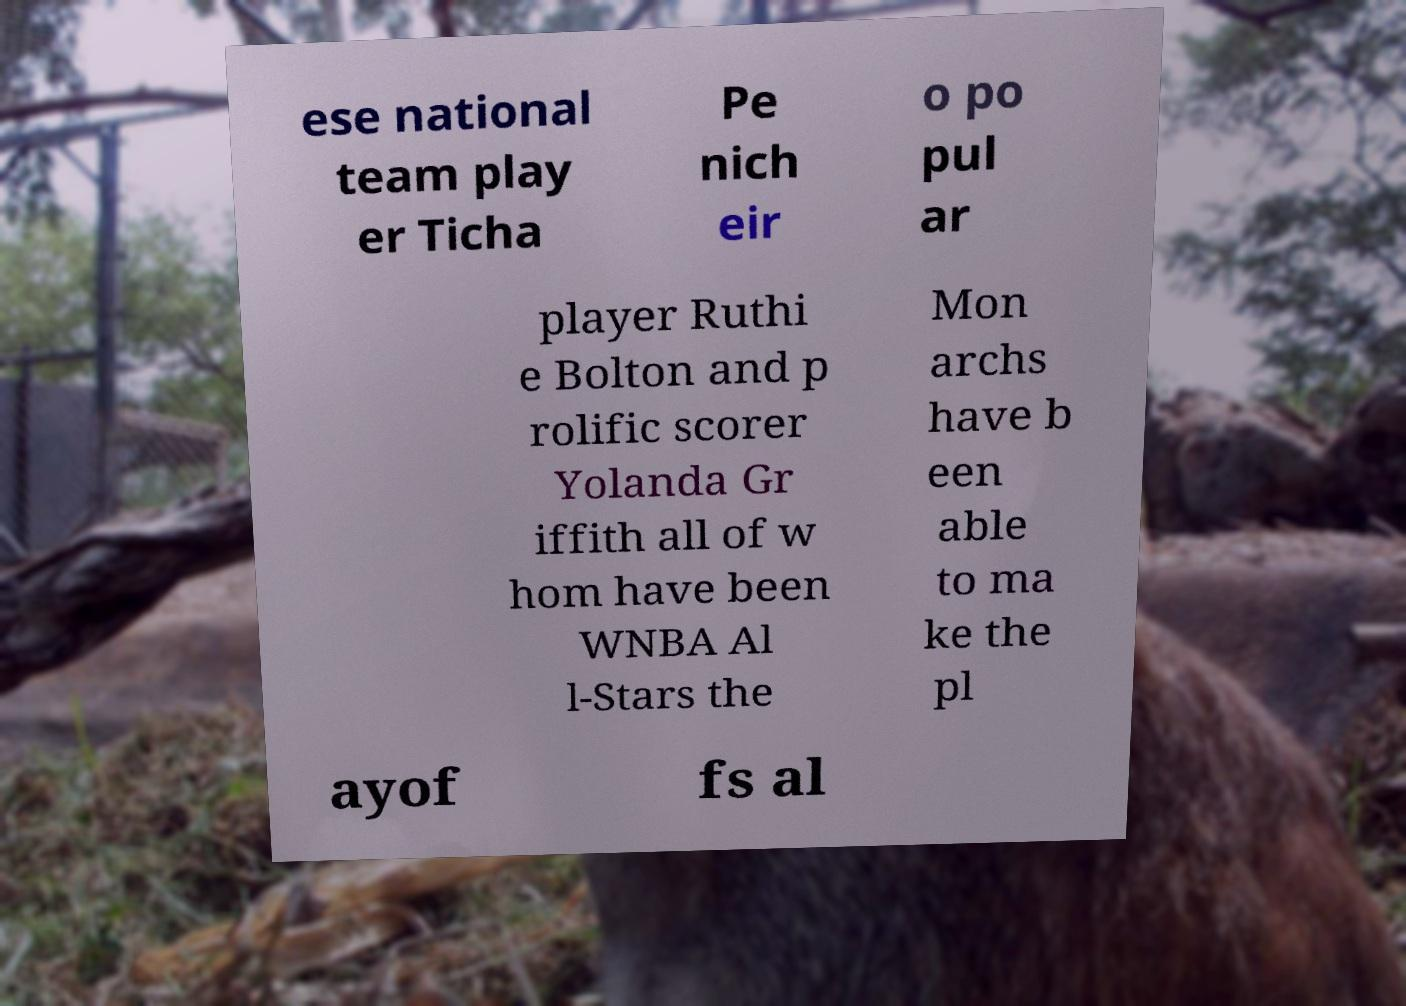What messages or text are displayed in this image? I need them in a readable, typed format. ese national team play er Ticha Pe nich eir o po pul ar player Ruthi e Bolton and p rolific scorer Yolanda Gr iffith all of w hom have been WNBA Al l-Stars the Mon archs have b een able to ma ke the pl ayof fs al 